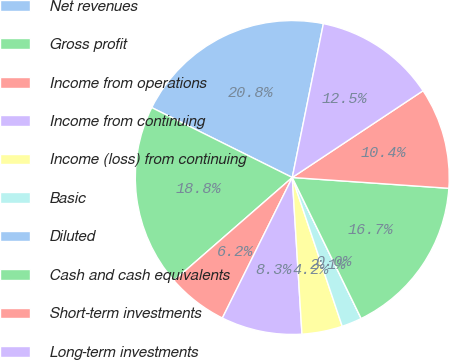<chart> <loc_0><loc_0><loc_500><loc_500><pie_chart><fcel>Net revenues<fcel>Gross profit<fcel>Income from operations<fcel>Income from continuing<fcel>Income (loss) from continuing<fcel>Basic<fcel>Diluted<fcel>Cash and cash equivalents<fcel>Short-term investments<fcel>Long-term investments<nl><fcel>20.83%<fcel>18.75%<fcel>6.25%<fcel>8.33%<fcel>4.17%<fcel>2.08%<fcel>0.0%<fcel>16.67%<fcel>10.42%<fcel>12.5%<nl></chart> 